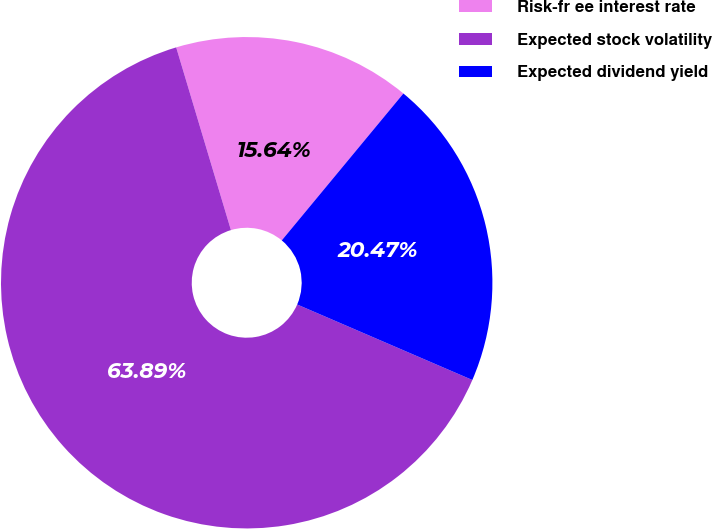Convert chart. <chart><loc_0><loc_0><loc_500><loc_500><pie_chart><fcel>Risk-fr ee interest rate<fcel>Expected stock volatility<fcel>Expected dividend yield<nl><fcel>15.64%<fcel>63.89%<fcel>20.47%<nl></chart> 